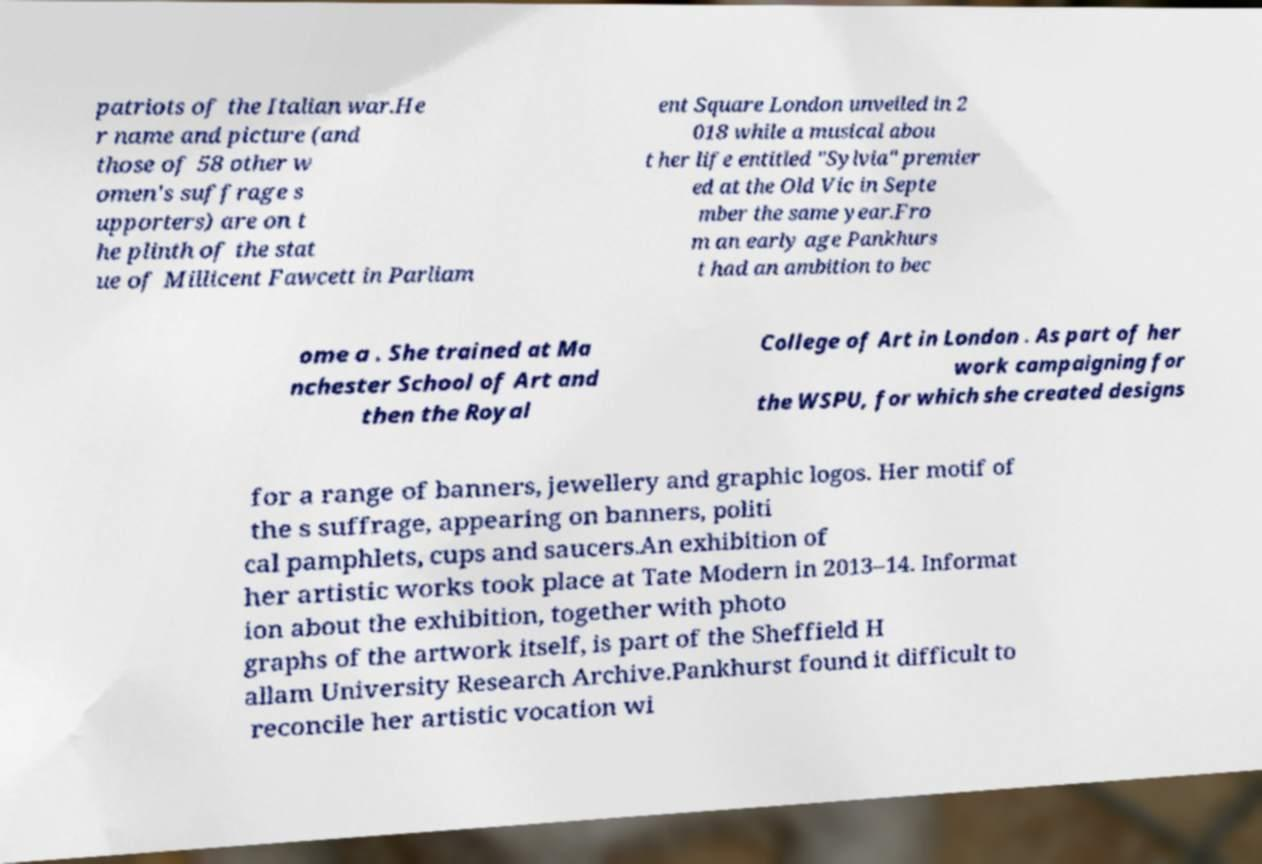Can you accurately transcribe the text from the provided image for me? patriots of the Italian war.He r name and picture (and those of 58 other w omen's suffrage s upporters) are on t he plinth of the stat ue of Millicent Fawcett in Parliam ent Square London unveiled in 2 018 while a musical abou t her life entitled "Sylvia" premier ed at the Old Vic in Septe mber the same year.Fro m an early age Pankhurs t had an ambition to bec ome a . She trained at Ma nchester School of Art and then the Royal College of Art in London . As part of her work campaigning for the WSPU, for which she created designs for a range of banners, jewellery and graphic logos. Her motif of the s suffrage, appearing on banners, politi cal pamphlets, cups and saucers.An exhibition of her artistic works took place at Tate Modern in 2013–14. Informat ion about the exhibition, together with photo graphs of the artwork itself, is part of the Sheffield H allam University Research Archive.Pankhurst found it difficult to reconcile her artistic vocation wi 